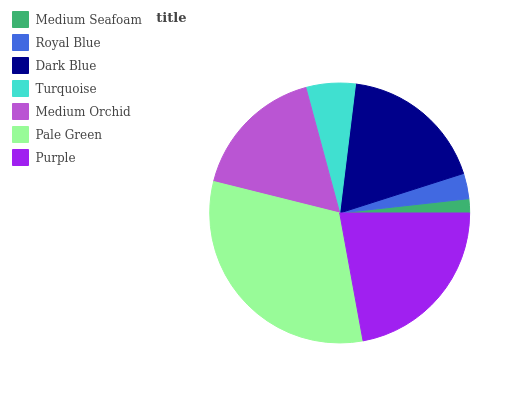Is Medium Seafoam the minimum?
Answer yes or no. Yes. Is Pale Green the maximum?
Answer yes or no. Yes. Is Royal Blue the minimum?
Answer yes or no. No. Is Royal Blue the maximum?
Answer yes or no. No. Is Royal Blue greater than Medium Seafoam?
Answer yes or no. Yes. Is Medium Seafoam less than Royal Blue?
Answer yes or no. Yes. Is Medium Seafoam greater than Royal Blue?
Answer yes or no. No. Is Royal Blue less than Medium Seafoam?
Answer yes or no. No. Is Medium Orchid the high median?
Answer yes or no. Yes. Is Medium Orchid the low median?
Answer yes or no. Yes. Is Purple the high median?
Answer yes or no. No. Is Pale Green the low median?
Answer yes or no. No. 